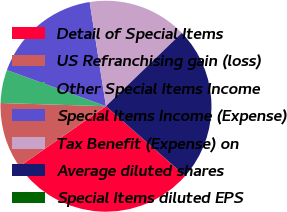<chart> <loc_0><loc_0><loc_500><loc_500><pie_chart><fcel>Detail of Special Items<fcel>US Refranchising gain (loss)<fcel>Other Special Items Income<fcel>Special Items Income (Expense)<fcel>Tax Benefit (Expense) on<fcel>Average diluted shares<fcel>Special Items diluted EPS<nl><fcel>28.81%<fcel>10.17%<fcel>5.09%<fcel>16.95%<fcel>15.25%<fcel>23.72%<fcel>0.01%<nl></chart> 